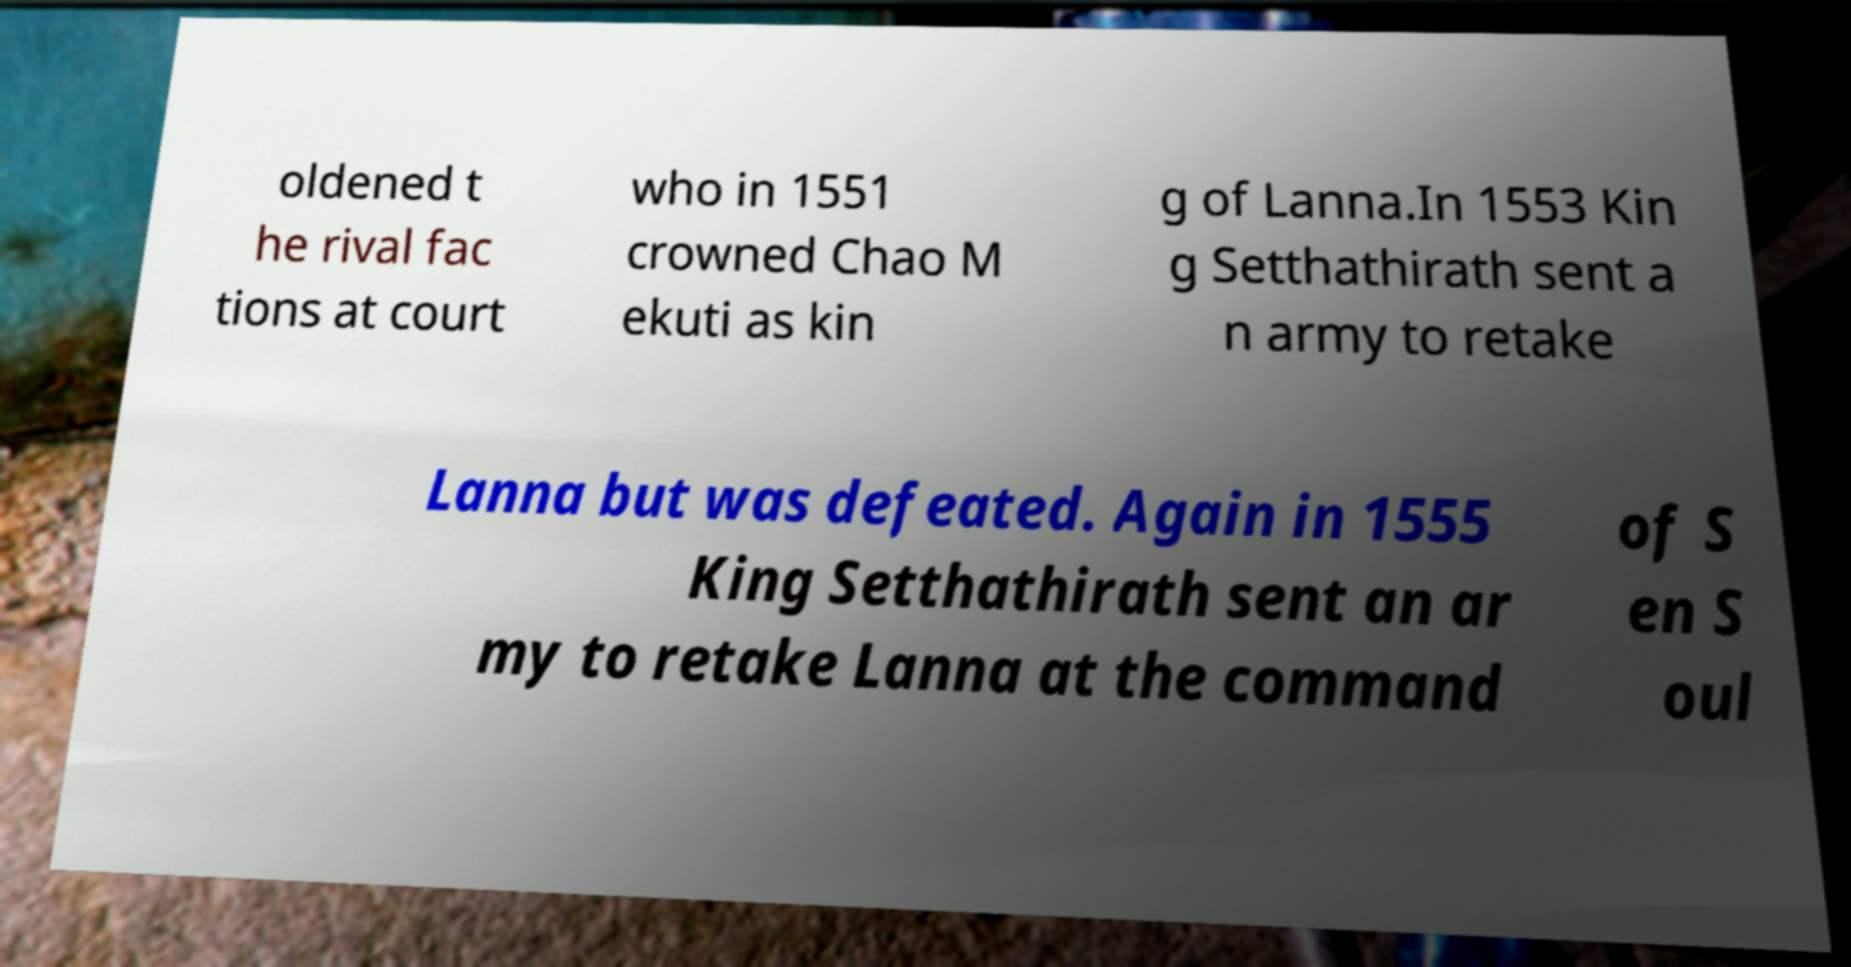For documentation purposes, I need the text within this image transcribed. Could you provide that? oldened t he rival fac tions at court who in 1551 crowned Chao M ekuti as kin g of Lanna.In 1553 Kin g Setthathirath sent a n army to retake Lanna but was defeated. Again in 1555 King Setthathirath sent an ar my to retake Lanna at the command of S en S oul 